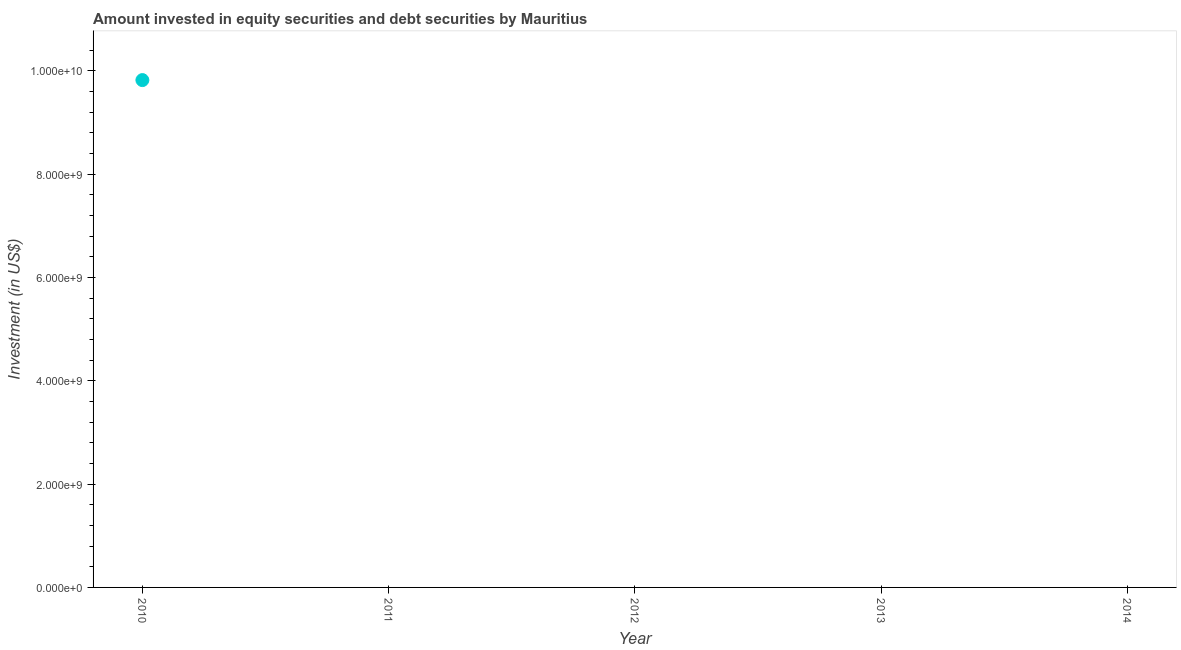Across all years, what is the maximum portfolio investment?
Your answer should be compact. 9.82e+09. Across all years, what is the minimum portfolio investment?
Ensure brevity in your answer.  0. What is the sum of the portfolio investment?
Make the answer very short. 9.82e+09. What is the average portfolio investment per year?
Provide a succinct answer. 1.96e+09. What is the median portfolio investment?
Provide a succinct answer. 0. What is the difference between the highest and the lowest portfolio investment?
Offer a very short reply. 9.82e+09. In how many years, is the portfolio investment greater than the average portfolio investment taken over all years?
Ensure brevity in your answer.  1. How many dotlines are there?
Provide a short and direct response. 1. How many years are there in the graph?
Offer a terse response. 5. What is the difference between two consecutive major ticks on the Y-axis?
Provide a short and direct response. 2.00e+09. Does the graph contain any zero values?
Offer a very short reply. Yes. What is the title of the graph?
Give a very brief answer. Amount invested in equity securities and debt securities by Mauritius. What is the label or title of the Y-axis?
Offer a terse response. Investment (in US$). What is the Investment (in US$) in 2010?
Your answer should be very brief. 9.82e+09. What is the Investment (in US$) in 2013?
Provide a short and direct response. 0. 